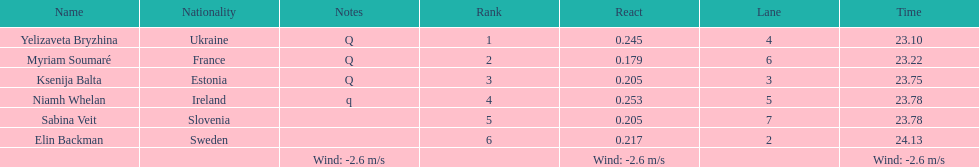Name of athlete who came in first in heat 1 of the women's 200 metres Yelizaveta Bryzhina. 